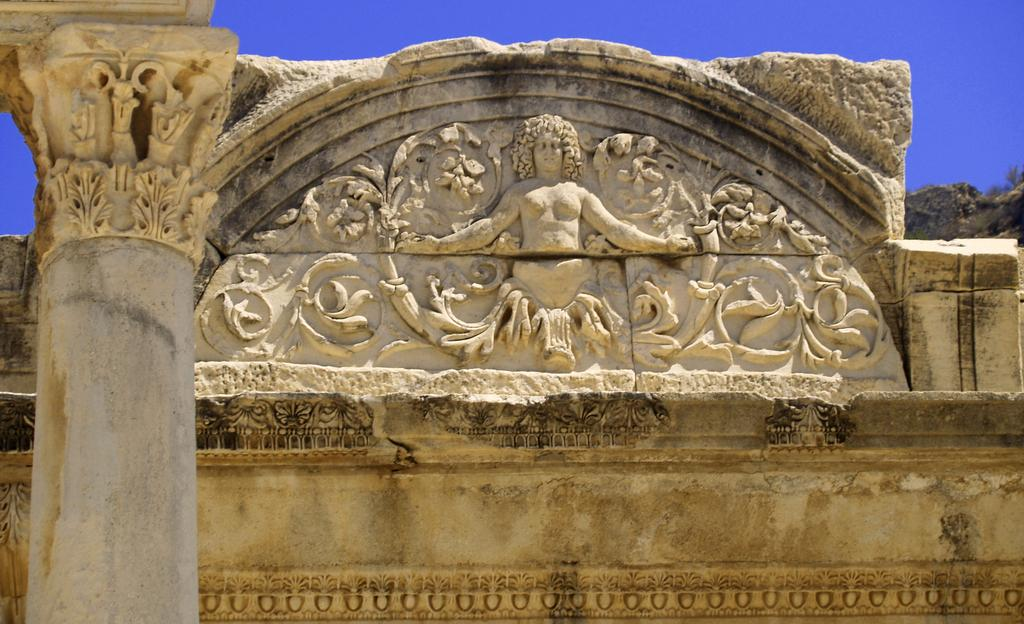What is located on the left side of the image? There is a pillar with carvings on the left side of the image. What can be seen on the wall in the image? There are carvings on the wall in the image. What is the color of the sky in the image? The sky is blue in color. Can you tell me how many cubs are playing near the laborer in the image? There is no laborer or cubs present in the image. What type of aircraft can be seen taking off at the airport in the image? There is no airport or aircraft present in the image. 